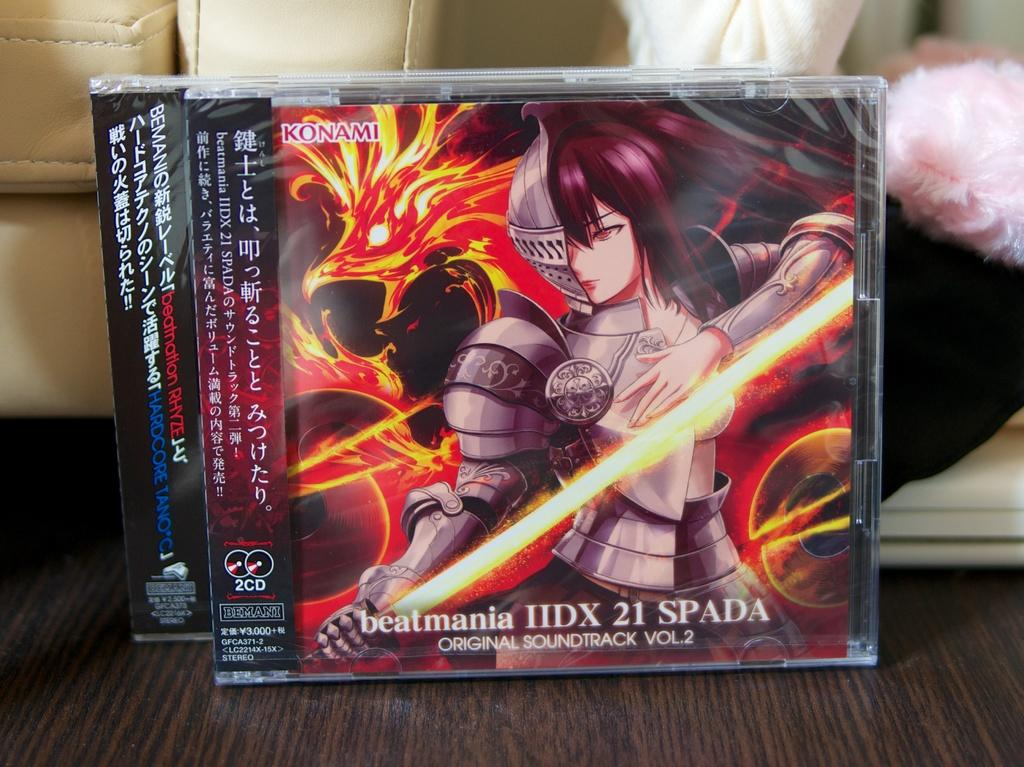Provide a one-sentence caption for the provided image. Konami game cases with anime characters on the front. 